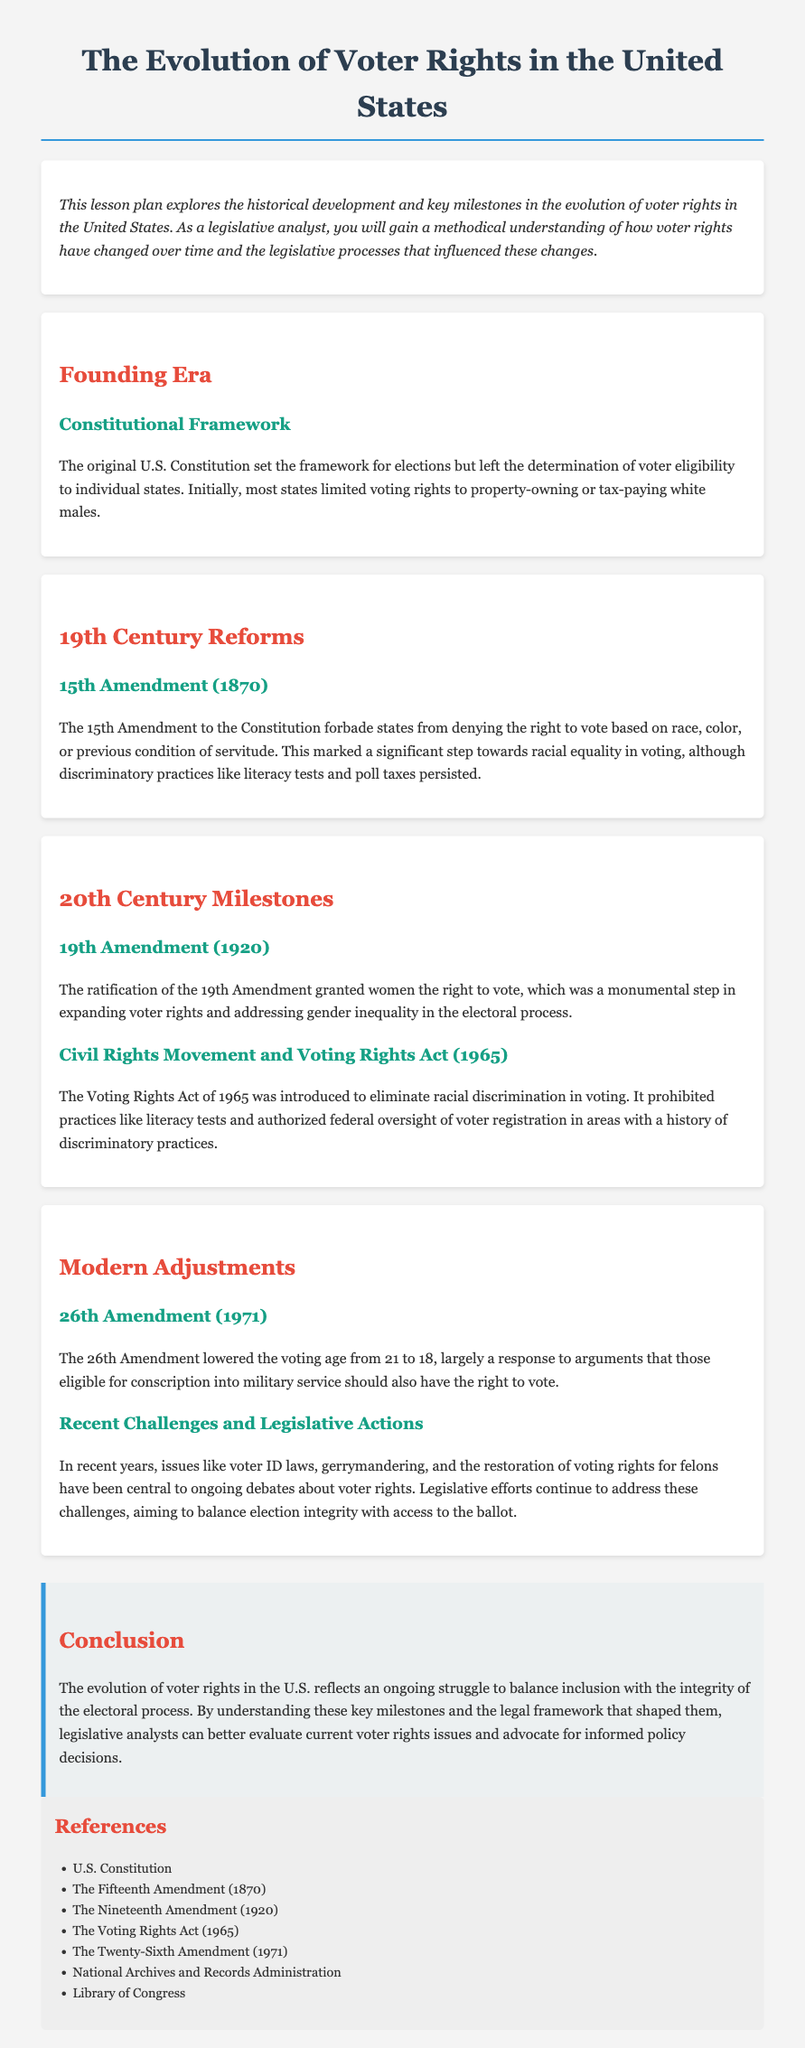What is the title of the lesson plan? The title of the lesson plan is stated in the document as "The Evolution of Voter Rights in the United States."
Answer: The Evolution of Voter Rights in the United States Which amendment forbade states from denying the right to vote based on race? The 15th Amendment (1870) is specifically mentioned as forbidding states from denying the right to vote based on race, color, or previous condition of servitude.
Answer: 15th Amendment What year was the 19th Amendment ratified? The document indicates that the 19th Amendment was ratified in the year 1920.
Answer: 1920 What significant act was passed in 1965 to eliminate racial discrimination in voting? The Voting Rights Act, mentioned in the document, was the significant act passed in 1965 to eliminate racial discrimination in voting.
Answer: Voting Rights Act What was the voting age changed to by the 26th Amendment? The 26th Amendment lowered the voting age to 18, as specified in the document.
Answer: 18 How did the original U.S. Constitution influence voter eligibility? The original U.S. Constitution left the determination of voter eligibility to individual states, which is a reasoning aspect of the document.
Answer: To individual states What ongoing issues are mentioned in recent challenges and legislative actions? The document lists voter ID laws, gerrymandering, and the restoration of voting rights for felons as ongoing issues.
Answer: Voter ID laws, gerrymandering, restoration of voting rights for felons What does the conclusion suggest about the evolution of voter rights? The conclusion emphasizes that the evolution of voter rights reflects an ongoing struggle to balance inclusion with the integrity of the electoral process.
Answer: Balance inclusion with the integrity of the electoral process 